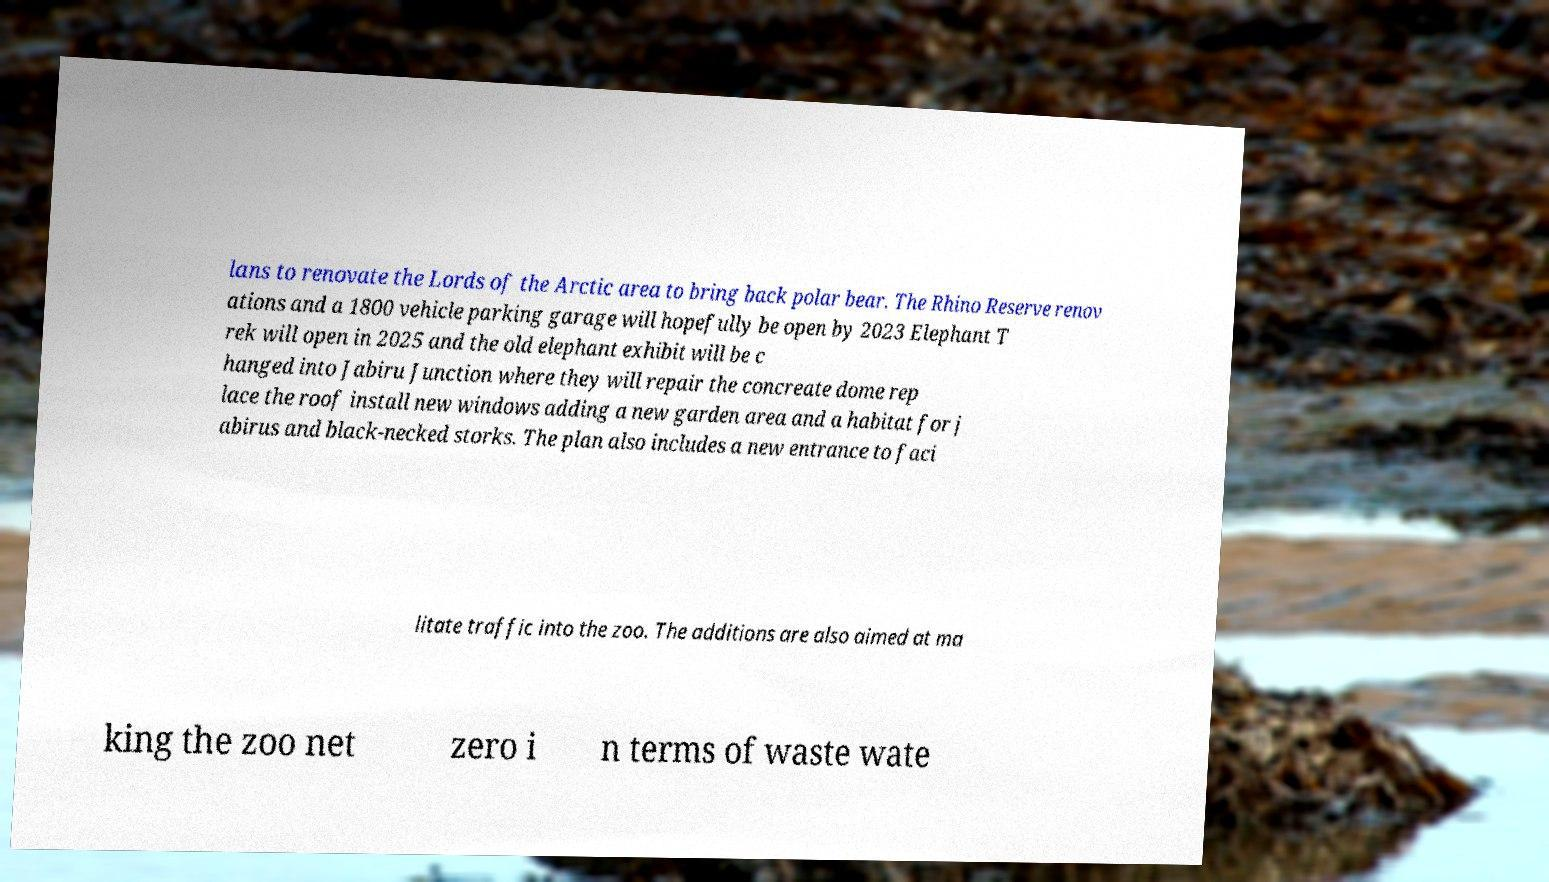For documentation purposes, I need the text within this image transcribed. Could you provide that? lans to renovate the Lords of the Arctic area to bring back polar bear. The Rhino Reserve renov ations and a 1800 vehicle parking garage will hopefully be open by 2023 Elephant T rek will open in 2025 and the old elephant exhibit will be c hanged into Jabiru Junction where they will repair the concreate dome rep lace the roof install new windows adding a new garden area and a habitat for j abirus and black-necked storks. The plan also includes a new entrance to faci litate traffic into the zoo. The additions are also aimed at ma king the zoo net zero i n terms of waste wate 